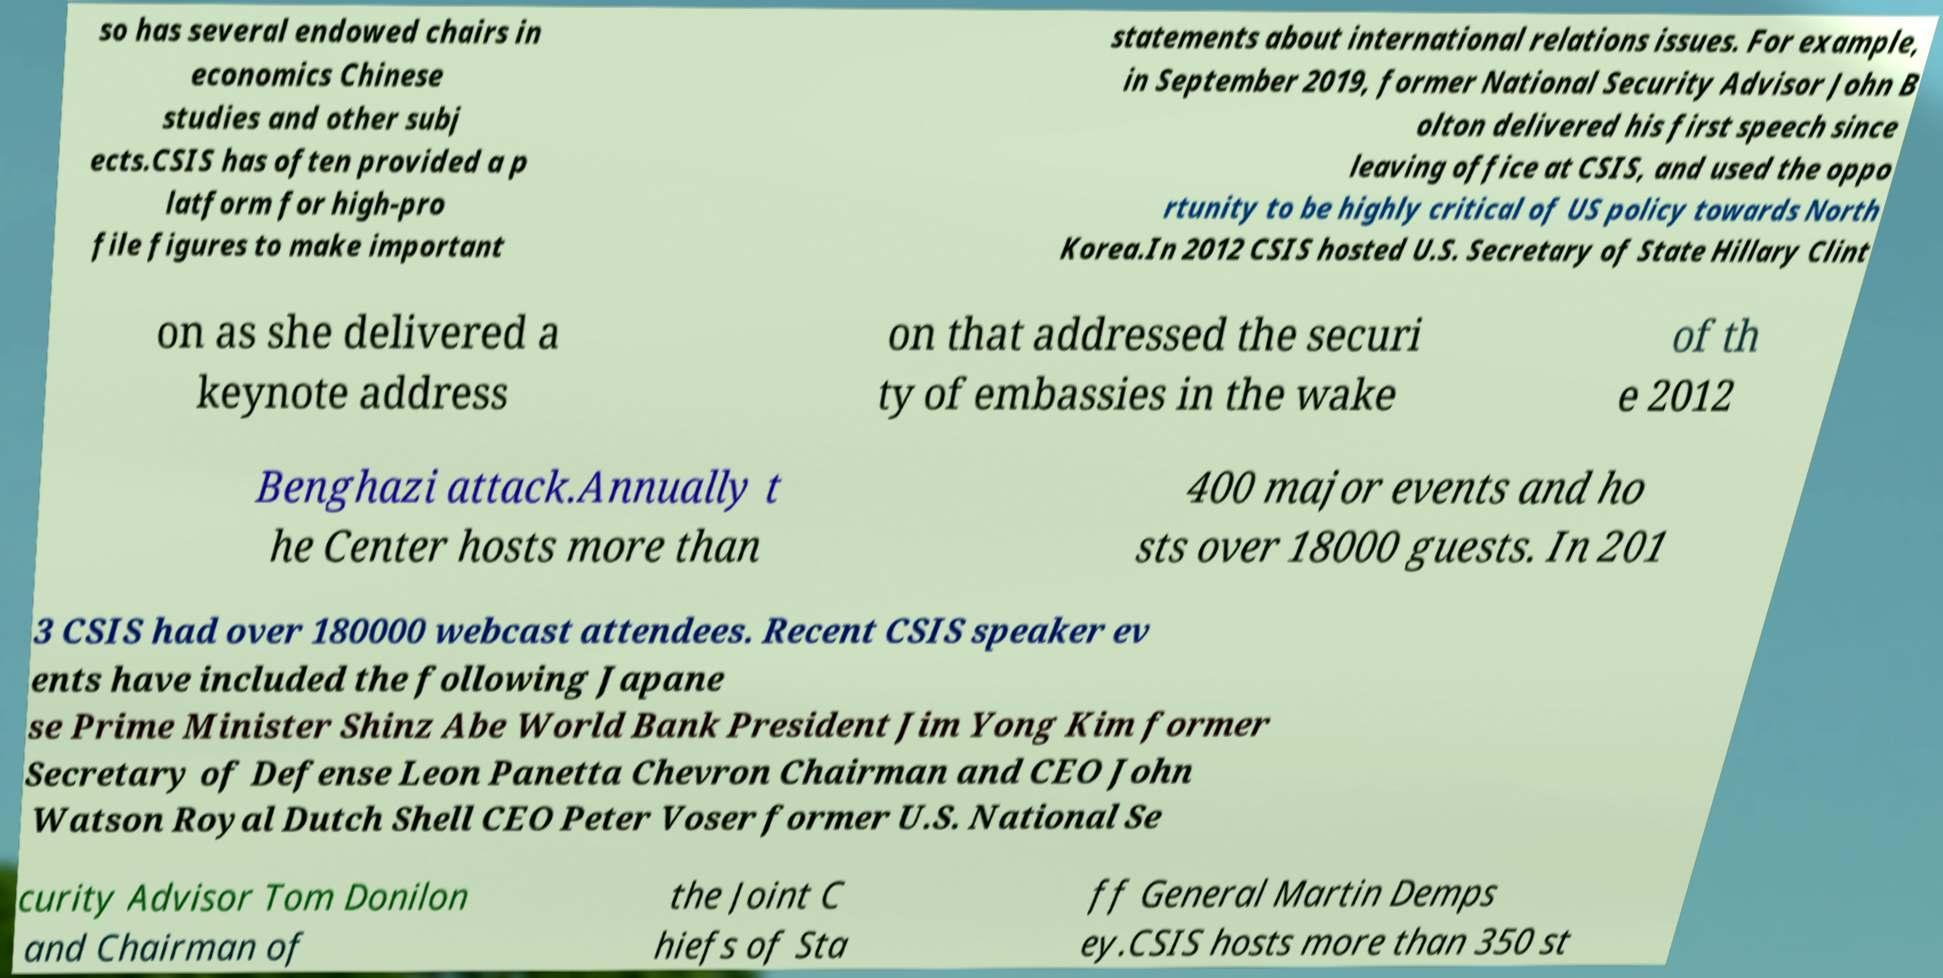Could you extract and type out the text from this image? so has several endowed chairs in economics Chinese studies and other subj ects.CSIS has often provided a p latform for high-pro file figures to make important statements about international relations issues. For example, in September 2019, former National Security Advisor John B olton delivered his first speech since leaving office at CSIS, and used the oppo rtunity to be highly critical of US policy towards North Korea.In 2012 CSIS hosted U.S. Secretary of State Hillary Clint on as she delivered a keynote address on that addressed the securi ty of embassies in the wake of th e 2012 Benghazi attack.Annually t he Center hosts more than 400 major events and ho sts over 18000 guests. In 201 3 CSIS had over 180000 webcast attendees. Recent CSIS speaker ev ents have included the following Japane se Prime Minister Shinz Abe World Bank President Jim Yong Kim former Secretary of Defense Leon Panetta Chevron Chairman and CEO John Watson Royal Dutch Shell CEO Peter Voser former U.S. National Se curity Advisor Tom Donilon and Chairman of the Joint C hiefs of Sta ff General Martin Demps ey.CSIS hosts more than 350 st 